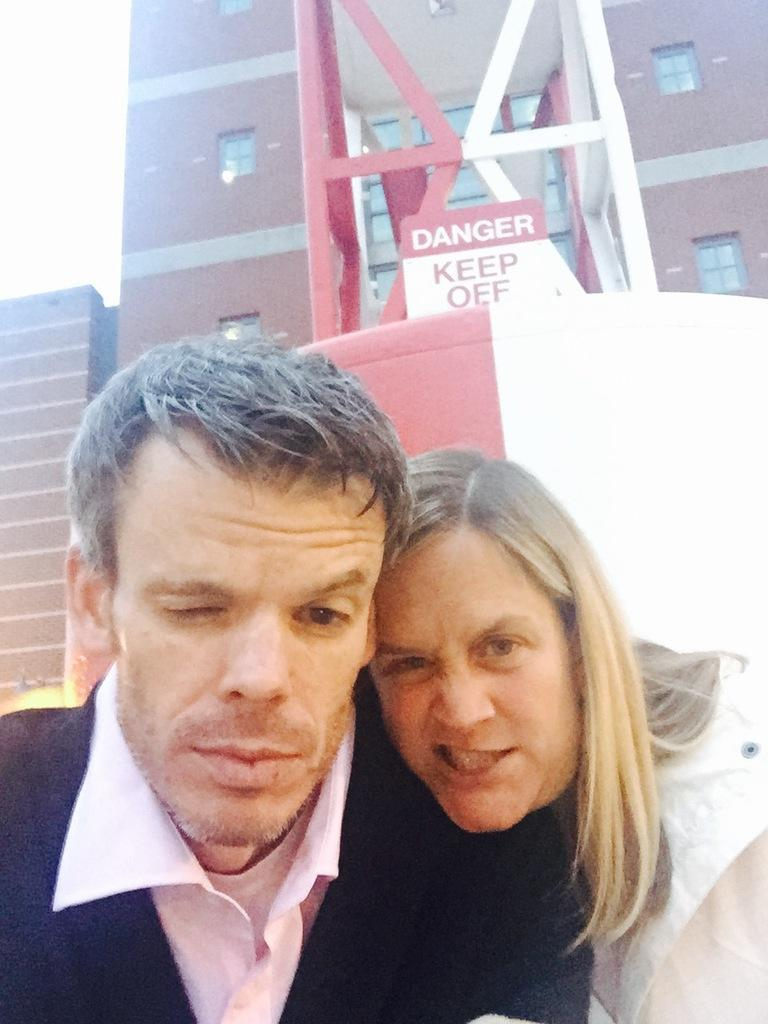Who can be seen in the foreground of the picture? There is a couple in the foreground of the picture. What is the main structure in the center of the picture? There is a tower in the center of the picture. What type of structure can be seen in the background of the picture? There is a building in the background of the picture. What is the zinc content of the tower in the image? There is no information about the zinc content of the tower in the image, as it is not mentioned in the provided facts. 